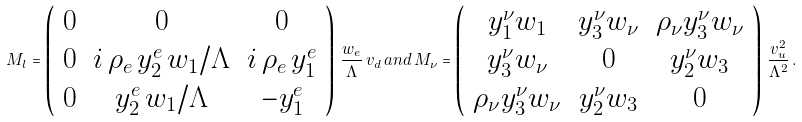Convert formula to latex. <formula><loc_0><loc_0><loc_500><loc_500>M _ { l } = \left ( \begin{array} { c c c } 0 & 0 & 0 \\ 0 & i \, \rho _ { e } \, y _ { 2 } ^ { e } \, w _ { 1 } / \Lambda & i \, \rho _ { e } \, y _ { 1 } ^ { e } \\ 0 & y _ { 2 } ^ { e } \, w _ { 1 } / \Lambda & - y _ { 1 } ^ { e } \end{array} \right ) \, \frac { w _ { e } } { \Lambda } \, v _ { d } \, a n d \, M _ { \nu } = \left ( \begin{array} { c c c } y _ { 1 } ^ { \nu } w _ { 1 } & y _ { 3 } ^ { \nu } w _ { \nu } & \rho _ { \nu } y _ { 3 } ^ { \nu } w _ { \nu } \\ y _ { 3 } ^ { \nu } w _ { \nu } & 0 & y _ { 2 } ^ { \nu } w _ { 3 } \\ \rho _ { \nu } y _ { 3 } ^ { \nu } w _ { \nu } & y _ { 2 } ^ { \nu } w _ { 3 } & 0 \end{array} \right ) \, \frac { v _ { u } ^ { 2 } } { \Lambda ^ { 2 } } \, .</formula> 